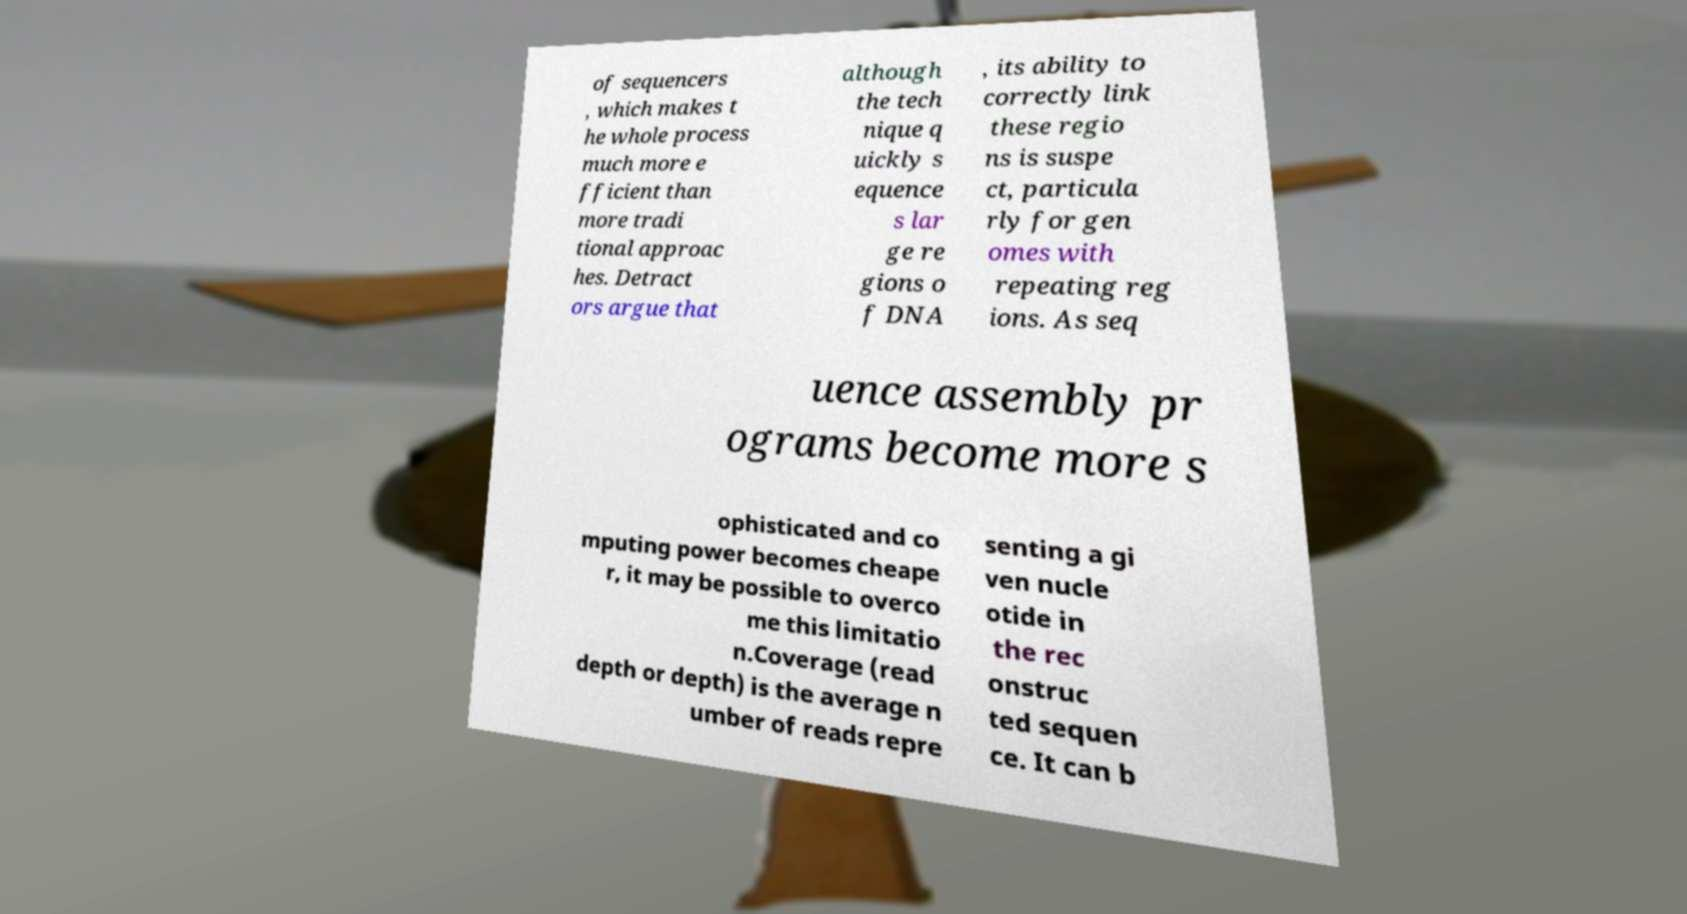Please identify and transcribe the text found in this image. of sequencers , which makes t he whole process much more e fficient than more tradi tional approac hes. Detract ors argue that although the tech nique q uickly s equence s lar ge re gions o f DNA , its ability to correctly link these regio ns is suspe ct, particula rly for gen omes with repeating reg ions. As seq uence assembly pr ograms become more s ophisticated and co mputing power becomes cheape r, it may be possible to overco me this limitatio n.Coverage (read depth or depth) is the average n umber of reads repre senting a gi ven nucle otide in the rec onstruc ted sequen ce. It can b 